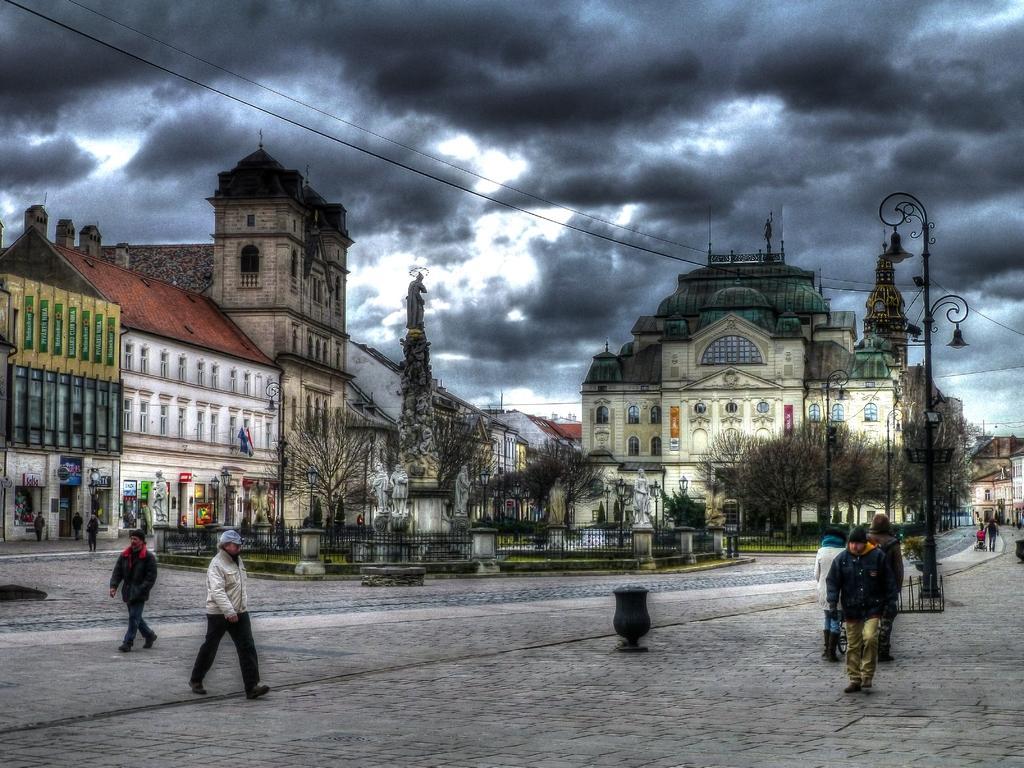Describe this image in one or two sentences. In this image I can see the ground, few persons standing on the ground, few poles, few wires, few trees, the railing and few buildings. In the background I can see the sky. 